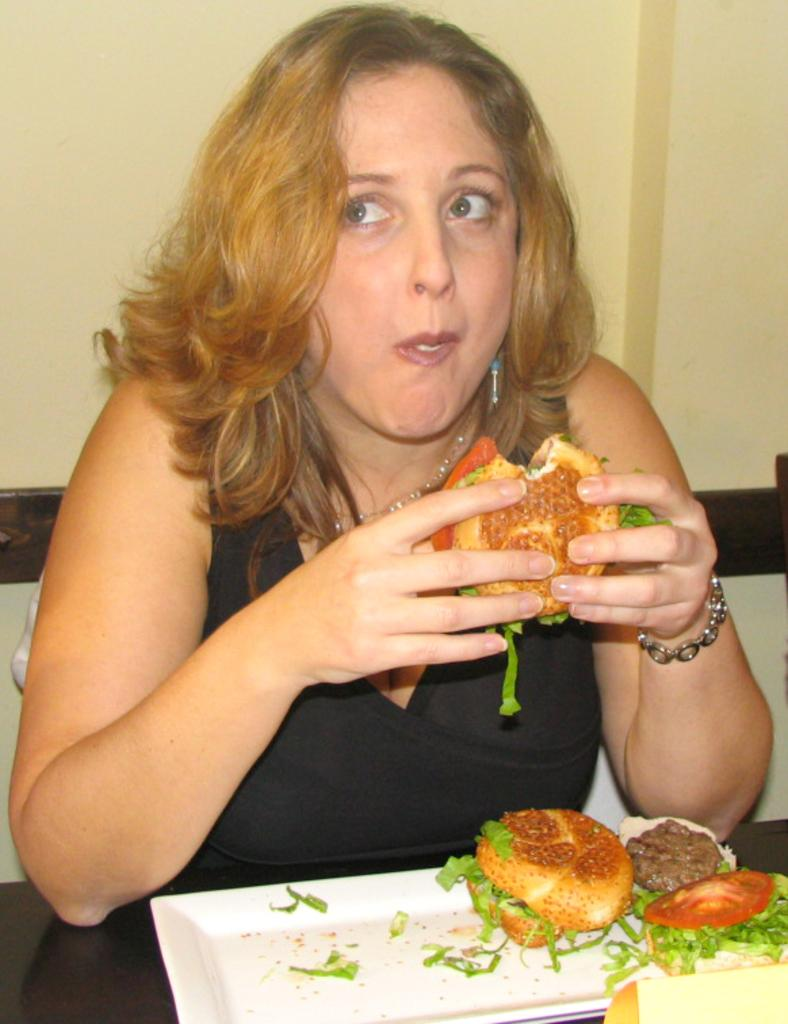Who is the main subject in the image? There is a person in the image. What is the person doing in the image? The person is eating a burger. Are there any other burgers visible in the image? Yes, there is another burger on a plate. What can be seen in the background of the image? There is a wall visible in the background of the image. What is the duck thinking while watching the person eat the burger in the image? There is no duck present in the image, so it is not possible to determine what a duck might be thinking. 